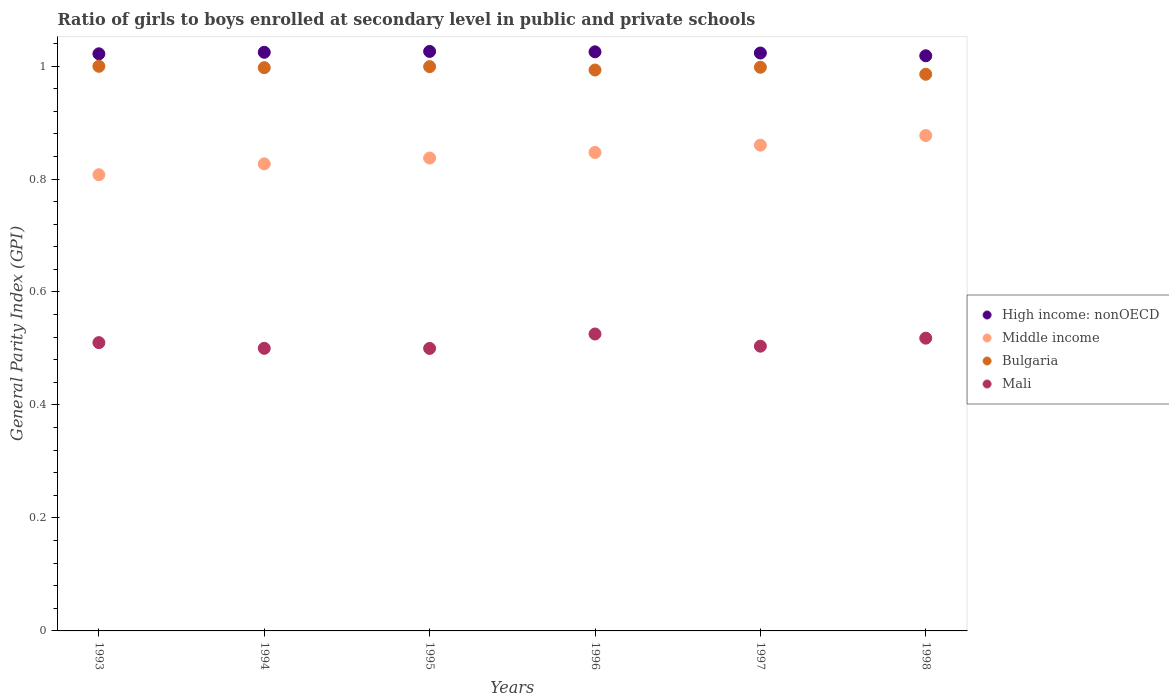How many different coloured dotlines are there?
Your response must be concise. 4. What is the general parity index in Bulgaria in 1995?
Your answer should be compact. 1. Across all years, what is the maximum general parity index in Middle income?
Make the answer very short. 0.88. Across all years, what is the minimum general parity index in Bulgaria?
Ensure brevity in your answer.  0.99. In which year was the general parity index in Bulgaria maximum?
Make the answer very short. 1993. What is the total general parity index in Bulgaria in the graph?
Provide a short and direct response. 5.97. What is the difference between the general parity index in Bulgaria in 1995 and that in 1996?
Offer a terse response. 0.01. What is the difference between the general parity index in Bulgaria in 1995 and the general parity index in Middle income in 1997?
Your response must be concise. 0.14. What is the average general parity index in Mali per year?
Make the answer very short. 0.51. In the year 1998, what is the difference between the general parity index in Bulgaria and general parity index in Mali?
Make the answer very short. 0.47. What is the ratio of the general parity index in Bulgaria in 1994 to that in 1996?
Make the answer very short. 1. What is the difference between the highest and the second highest general parity index in High income: nonOECD?
Your answer should be very brief. 0. What is the difference between the highest and the lowest general parity index in High income: nonOECD?
Make the answer very short. 0.01. Is the sum of the general parity index in Middle income in 1993 and 1994 greater than the maximum general parity index in Mali across all years?
Your answer should be very brief. Yes. Is it the case that in every year, the sum of the general parity index in Mali and general parity index in High income: nonOECD  is greater than the sum of general parity index in Bulgaria and general parity index in Middle income?
Your response must be concise. Yes. Is it the case that in every year, the sum of the general parity index in High income: nonOECD and general parity index in Middle income  is greater than the general parity index in Mali?
Your answer should be compact. Yes. Does the general parity index in Bulgaria monotonically increase over the years?
Your answer should be compact. No. Is the general parity index in Mali strictly greater than the general parity index in Bulgaria over the years?
Ensure brevity in your answer.  No. How many years are there in the graph?
Your answer should be compact. 6. Are the values on the major ticks of Y-axis written in scientific E-notation?
Your answer should be compact. No. How are the legend labels stacked?
Offer a very short reply. Vertical. What is the title of the graph?
Provide a short and direct response. Ratio of girls to boys enrolled at secondary level in public and private schools. What is the label or title of the Y-axis?
Give a very brief answer. General Parity Index (GPI). What is the General Parity Index (GPI) of High income: nonOECD in 1993?
Make the answer very short. 1.02. What is the General Parity Index (GPI) of Middle income in 1993?
Your answer should be compact. 0.81. What is the General Parity Index (GPI) in Bulgaria in 1993?
Give a very brief answer. 1. What is the General Parity Index (GPI) in Mali in 1993?
Keep it short and to the point. 0.51. What is the General Parity Index (GPI) in High income: nonOECD in 1994?
Offer a very short reply. 1.02. What is the General Parity Index (GPI) in Middle income in 1994?
Your answer should be very brief. 0.83. What is the General Parity Index (GPI) in Bulgaria in 1994?
Your response must be concise. 1. What is the General Parity Index (GPI) of Mali in 1994?
Ensure brevity in your answer.  0.5. What is the General Parity Index (GPI) in High income: nonOECD in 1995?
Give a very brief answer. 1.03. What is the General Parity Index (GPI) in Middle income in 1995?
Offer a terse response. 0.84. What is the General Parity Index (GPI) in Bulgaria in 1995?
Provide a short and direct response. 1. What is the General Parity Index (GPI) in Mali in 1995?
Provide a succinct answer. 0.5. What is the General Parity Index (GPI) of High income: nonOECD in 1996?
Provide a succinct answer. 1.03. What is the General Parity Index (GPI) in Middle income in 1996?
Offer a terse response. 0.85. What is the General Parity Index (GPI) of Bulgaria in 1996?
Provide a short and direct response. 0.99. What is the General Parity Index (GPI) of Mali in 1996?
Your answer should be very brief. 0.53. What is the General Parity Index (GPI) of High income: nonOECD in 1997?
Offer a terse response. 1.02. What is the General Parity Index (GPI) of Middle income in 1997?
Provide a short and direct response. 0.86. What is the General Parity Index (GPI) in Bulgaria in 1997?
Make the answer very short. 1. What is the General Parity Index (GPI) in Mali in 1997?
Your response must be concise. 0.5. What is the General Parity Index (GPI) of High income: nonOECD in 1998?
Keep it short and to the point. 1.02. What is the General Parity Index (GPI) of Middle income in 1998?
Make the answer very short. 0.88. What is the General Parity Index (GPI) in Bulgaria in 1998?
Your answer should be compact. 0.99. What is the General Parity Index (GPI) of Mali in 1998?
Provide a short and direct response. 0.52. Across all years, what is the maximum General Parity Index (GPI) in High income: nonOECD?
Keep it short and to the point. 1.03. Across all years, what is the maximum General Parity Index (GPI) of Middle income?
Provide a succinct answer. 0.88. Across all years, what is the maximum General Parity Index (GPI) of Bulgaria?
Offer a very short reply. 1. Across all years, what is the maximum General Parity Index (GPI) of Mali?
Make the answer very short. 0.53. Across all years, what is the minimum General Parity Index (GPI) in High income: nonOECD?
Provide a short and direct response. 1.02. Across all years, what is the minimum General Parity Index (GPI) in Middle income?
Give a very brief answer. 0.81. Across all years, what is the minimum General Parity Index (GPI) of Bulgaria?
Provide a short and direct response. 0.99. Across all years, what is the minimum General Parity Index (GPI) in Mali?
Keep it short and to the point. 0.5. What is the total General Parity Index (GPI) in High income: nonOECD in the graph?
Your answer should be very brief. 6.14. What is the total General Parity Index (GPI) of Middle income in the graph?
Offer a terse response. 5.06. What is the total General Parity Index (GPI) in Bulgaria in the graph?
Keep it short and to the point. 5.97. What is the total General Parity Index (GPI) of Mali in the graph?
Make the answer very short. 3.06. What is the difference between the General Parity Index (GPI) of High income: nonOECD in 1993 and that in 1994?
Make the answer very short. -0. What is the difference between the General Parity Index (GPI) in Middle income in 1993 and that in 1994?
Give a very brief answer. -0.02. What is the difference between the General Parity Index (GPI) of Bulgaria in 1993 and that in 1994?
Provide a succinct answer. 0. What is the difference between the General Parity Index (GPI) in Mali in 1993 and that in 1994?
Provide a succinct answer. 0.01. What is the difference between the General Parity Index (GPI) of High income: nonOECD in 1993 and that in 1995?
Make the answer very short. -0. What is the difference between the General Parity Index (GPI) of Middle income in 1993 and that in 1995?
Offer a very short reply. -0.03. What is the difference between the General Parity Index (GPI) of Bulgaria in 1993 and that in 1995?
Your answer should be compact. 0. What is the difference between the General Parity Index (GPI) of Mali in 1993 and that in 1995?
Ensure brevity in your answer.  0.01. What is the difference between the General Parity Index (GPI) in High income: nonOECD in 1993 and that in 1996?
Your answer should be compact. -0. What is the difference between the General Parity Index (GPI) in Middle income in 1993 and that in 1996?
Provide a short and direct response. -0.04. What is the difference between the General Parity Index (GPI) in Bulgaria in 1993 and that in 1996?
Provide a succinct answer. 0.01. What is the difference between the General Parity Index (GPI) of Mali in 1993 and that in 1996?
Provide a succinct answer. -0.02. What is the difference between the General Parity Index (GPI) in High income: nonOECD in 1993 and that in 1997?
Offer a very short reply. -0. What is the difference between the General Parity Index (GPI) of Middle income in 1993 and that in 1997?
Your answer should be compact. -0.05. What is the difference between the General Parity Index (GPI) of Bulgaria in 1993 and that in 1997?
Keep it short and to the point. 0. What is the difference between the General Parity Index (GPI) of Mali in 1993 and that in 1997?
Ensure brevity in your answer.  0.01. What is the difference between the General Parity Index (GPI) of High income: nonOECD in 1993 and that in 1998?
Your answer should be compact. 0. What is the difference between the General Parity Index (GPI) in Middle income in 1993 and that in 1998?
Ensure brevity in your answer.  -0.07. What is the difference between the General Parity Index (GPI) of Bulgaria in 1993 and that in 1998?
Offer a very short reply. 0.01. What is the difference between the General Parity Index (GPI) of Mali in 1993 and that in 1998?
Give a very brief answer. -0.01. What is the difference between the General Parity Index (GPI) in High income: nonOECD in 1994 and that in 1995?
Your answer should be compact. -0. What is the difference between the General Parity Index (GPI) in Middle income in 1994 and that in 1995?
Provide a succinct answer. -0.01. What is the difference between the General Parity Index (GPI) in Bulgaria in 1994 and that in 1995?
Offer a very short reply. -0. What is the difference between the General Parity Index (GPI) of High income: nonOECD in 1994 and that in 1996?
Keep it short and to the point. -0. What is the difference between the General Parity Index (GPI) of Middle income in 1994 and that in 1996?
Make the answer very short. -0.02. What is the difference between the General Parity Index (GPI) of Bulgaria in 1994 and that in 1996?
Your response must be concise. 0. What is the difference between the General Parity Index (GPI) of Mali in 1994 and that in 1996?
Keep it short and to the point. -0.03. What is the difference between the General Parity Index (GPI) in High income: nonOECD in 1994 and that in 1997?
Give a very brief answer. 0. What is the difference between the General Parity Index (GPI) in Middle income in 1994 and that in 1997?
Your answer should be very brief. -0.03. What is the difference between the General Parity Index (GPI) of Bulgaria in 1994 and that in 1997?
Give a very brief answer. -0. What is the difference between the General Parity Index (GPI) of Mali in 1994 and that in 1997?
Provide a short and direct response. -0. What is the difference between the General Parity Index (GPI) in High income: nonOECD in 1994 and that in 1998?
Give a very brief answer. 0.01. What is the difference between the General Parity Index (GPI) in Middle income in 1994 and that in 1998?
Offer a very short reply. -0.05. What is the difference between the General Parity Index (GPI) in Bulgaria in 1994 and that in 1998?
Give a very brief answer. 0.01. What is the difference between the General Parity Index (GPI) of Mali in 1994 and that in 1998?
Keep it short and to the point. -0.02. What is the difference between the General Parity Index (GPI) in High income: nonOECD in 1995 and that in 1996?
Give a very brief answer. 0. What is the difference between the General Parity Index (GPI) of Middle income in 1995 and that in 1996?
Ensure brevity in your answer.  -0.01. What is the difference between the General Parity Index (GPI) in Bulgaria in 1995 and that in 1996?
Provide a short and direct response. 0.01. What is the difference between the General Parity Index (GPI) of Mali in 1995 and that in 1996?
Ensure brevity in your answer.  -0.03. What is the difference between the General Parity Index (GPI) in High income: nonOECD in 1995 and that in 1997?
Offer a terse response. 0. What is the difference between the General Parity Index (GPI) in Middle income in 1995 and that in 1997?
Make the answer very short. -0.02. What is the difference between the General Parity Index (GPI) of Bulgaria in 1995 and that in 1997?
Give a very brief answer. 0. What is the difference between the General Parity Index (GPI) of Mali in 1995 and that in 1997?
Your answer should be compact. -0. What is the difference between the General Parity Index (GPI) of High income: nonOECD in 1995 and that in 1998?
Your response must be concise. 0.01. What is the difference between the General Parity Index (GPI) in Middle income in 1995 and that in 1998?
Ensure brevity in your answer.  -0.04. What is the difference between the General Parity Index (GPI) in Bulgaria in 1995 and that in 1998?
Make the answer very short. 0.01. What is the difference between the General Parity Index (GPI) of Mali in 1995 and that in 1998?
Your answer should be compact. -0.02. What is the difference between the General Parity Index (GPI) in High income: nonOECD in 1996 and that in 1997?
Offer a terse response. 0. What is the difference between the General Parity Index (GPI) in Middle income in 1996 and that in 1997?
Your answer should be very brief. -0.01. What is the difference between the General Parity Index (GPI) of Bulgaria in 1996 and that in 1997?
Your answer should be compact. -0. What is the difference between the General Parity Index (GPI) of Mali in 1996 and that in 1997?
Your answer should be very brief. 0.02. What is the difference between the General Parity Index (GPI) in High income: nonOECD in 1996 and that in 1998?
Provide a short and direct response. 0.01. What is the difference between the General Parity Index (GPI) in Middle income in 1996 and that in 1998?
Your answer should be very brief. -0.03. What is the difference between the General Parity Index (GPI) of Bulgaria in 1996 and that in 1998?
Offer a very short reply. 0.01. What is the difference between the General Parity Index (GPI) of Mali in 1996 and that in 1998?
Your answer should be compact. 0.01. What is the difference between the General Parity Index (GPI) in High income: nonOECD in 1997 and that in 1998?
Your response must be concise. 0. What is the difference between the General Parity Index (GPI) in Middle income in 1997 and that in 1998?
Keep it short and to the point. -0.02. What is the difference between the General Parity Index (GPI) in Bulgaria in 1997 and that in 1998?
Provide a short and direct response. 0.01. What is the difference between the General Parity Index (GPI) in Mali in 1997 and that in 1998?
Ensure brevity in your answer.  -0.01. What is the difference between the General Parity Index (GPI) of High income: nonOECD in 1993 and the General Parity Index (GPI) of Middle income in 1994?
Keep it short and to the point. 0.19. What is the difference between the General Parity Index (GPI) in High income: nonOECD in 1993 and the General Parity Index (GPI) in Bulgaria in 1994?
Your response must be concise. 0.02. What is the difference between the General Parity Index (GPI) in High income: nonOECD in 1993 and the General Parity Index (GPI) in Mali in 1994?
Give a very brief answer. 0.52. What is the difference between the General Parity Index (GPI) of Middle income in 1993 and the General Parity Index (GPI) of Bulgaria in 1994?
Your answer should be compact. -0.19. What is the difference between the General Parity Index (GPI) in Middle income in 1993 and the General Parity Index (GPI) in Mali in 1994?
Provide a succinct answer. 0.31. What is the difference between the General Parity Index (GPI) of Bulgaria in 1993 and the General Parity Index (GPI) of Mali in 1994?
Keep it short and to the point. 0.5. What is the difference between the General Parity Index (GPI) in High income: nonOECD in 1993 and the General Parity Index (GPI) in Middle income in 1995?
Keep it short and to the point. 0.18. What is the difference between the General Parity Index (GPI) of High income: nonOECD in 1993 and the General Parity Index (GPI) of Bulgaria in 1995?
Make the answer very short. 0.02. What is the difference between the General Parity Index (GPI) in High income: nonOECD in 1993 and the General Parity Index (GPI) in Mali in 1995?
Provide a short and direct response. 0.52. What is the difference between the General Parity Index (GPI) in Middle income in 1993 and the General Parity Index (GPI) in Bulgaria in 1995?
Ensure brevity in your answer.  -0.19. What is the difference between the General Parity Index (GPI) of Middle income in 1993 and the General Parity Index (GPI) of Mali in 1995?
Offer a very short reply. 0.31. What is the difference between the General Parity Index (GPI) in Bulgaria in 1993 and the General Parity Index (GPI) in Mali in 1995?
Offer a very short reply. 0.5. What is the difference between the General Parity Index (GPI) in High income: nonOECD in 1993 and the General Parity Index (GPI) in Middle income in 1996?
Offer a terse response. 0.17. What is the difference between the General Parity Index (GPI) of High income: nonOECD in 1993 and the General Parity Index (GPI) of Bulgaria in 1996?
Ensure brevity in your answer.  0.03. What is the difference between the General Parity Index (GPI) of High income: nonOECD in 1993 and the General Parity Index (GPI) of Mali in 1996?
Make the answer very short. 0.5. What is the difference between the General Parity Index (GPI) of Middle income in 1993 and the General Parity Index (GPI) of Bulgaria in 1996?
Keep it short and to the point. -0.19. What is the difference between the General Parity Index (GPI) of Middle income in 1993 and the General Parity Index (GPI) of Mali in 1996?
Offer a very short reply. 0.28. What is the difference between the General Parity Index (GPI) in Bulgaria in 1993 and the General Parity Index (GPI) in Mali in 1996?
Offer a very short reply. 0.47. What is the difference between the General Parity Index (GPI) of High income: nonOECD in 1993 and the General Parity Index (GPI) of Middle income in 1997?
Offer a terse response. 0.16. What is the difference between the General Parity Index (GPI) of High income: nonOECD in 1993 and the General Parity Index (GPI) of Bulgaria in 1997?
Offer a terse response. 0.02. What is the difference between the General Parity Index (GPI) in High income: nonOECD in 1993 and the General Parity Index (GPI) in Mali in 1997?
Offer a terse response. 0.52. What is the difference between the General Parity Index (GPI) in Middle income in 1993 and the General Parity Index (GPI) in Bulgaria in 1997?
Provide a short and direct response. -0.19. What is the difference between the General Parity Index (GPI) in Middle income in 1993 and the General Parity Index (GPI) in Mali in 1997?
Give a very brief answer. 0.3. What is the difference between the General Parity Index (GPI) in Bulgaria in 1993 and the General Parity Index (GPI) in Mali in 1997?
Offer a terse response. 0.5. What is the difference between the General Parity Index (GPI) of High income: nonOECD in 1993 and the General Parity Index (GPI) of Middle income in 1998?
Provide a short and direct response. 0.14. What is the difference between the General Parity Index (GPI) in High income: nonOECD in 1993 and the General Parity Index (GPI) in Bulgaria in 1998?
Offer a terse response. 0.04. What is the difference between the General Parity Index (GPI) of High income: nonOECD in 1993 and the General Parity Index (GPI) of Mali in 1998?
Keep it short and to the point. 0.5. What is the difference between the General Parity Index (GPI) of Middle income in 1993 and the General Parity Index (GPI) of Bulgaria in 1998?
Offer a terse response. -0.18. What is the difference between the General Parity Index (GPI) in Middle income in 1993 and the General Parity Index (GPI) in Mali in 1998?
Provide a succinct answer. 0.29. What is the difference between the General Parity Index (GPI) of Bulgaria in 1993 and the General Parity Index (GPI) of Mali in 1998?
Offer a very short reply. 0.48. What is the difference between the General Parity Index (GPI) in High income: nonOECD in 1994 and the General Parity Index (GPI) in Middle income in 1995?
Ensure brevity in your answer.  0.19. What is the difference between the General Parity Index (GPI) of High income: nonOECD in 1994 and the General Parity Index (GPI) of Bulgaria in 1995?
Your response must be concise. 0.03. What is the difference between the General Parity Index (GPI) of High income: nonOECD in 1994 and the General Parity Index (GPI) of Mali in 1995?
Keep it short and to the point. 0.52. What is the difference between the General Parity Index (GPI) in Middle income in 1994 and the General Parity Index (GPI) in Bulgaria in 1995?
Ensure brevity in your answer.  -0.17. What is the difference between the General Parity Index (GPI) of Middle income in 1994 and the General Parity Index (GPI) of Mali in 1995?
Give a very brief answer. 0.33. What is the difference between the General Parity Index (GPI) in Bulgaria in 1994 and the General Parity Index (GPI) in Mali in 1995?
Give a very brief answer. 0.5. What is the difference between the General Parity Index (GPI) in High income: nonOECD in 1994 and the General Parity Index (GPI) in Middle income in 1996?
Your response must be concise. 0.18. What is the difference between the General Parity Index (GPI) of High income: nonOECD in 1994 and the General Parity Index (GPI) of Bulgaria in 1996?
Provide a succinct answer. 0.03. What is the difference between the General Parity Index (GPI) of High income: nonOECD in 1994 and the General Parity Index (GPI) of Mali in 1996?
Provide a short and direct response. 0.5. What is the difference between the General Parity Index (GPI) in Middle income in 1994 and the General Parity Index (GPI) in Bulgaria in 1996?
Provide a succinct answer. -0.17. What is the difference between the General Parity Index (GPI) of Middle income in 1994 and the General Parity Index (GPI) of Mali in 1996?
Your response must be concise. 0.3. What is the difference between the General Parity Index (GPI) in Bulgaria in 1994 and the General Parity Index (GPI) in Mali in 1996?
Keep it short and to the point. 0.47. What is the difference between the General Parity Index (GPI) in High income: nonOECD in 1994 and the General Parity Index (GPI) in Middle income in 1997?
Your answer should be very brief. 0.16. What is the difference between the General Parity Index (GPI) of High income: nonOECD in 1994 and the General Parity Index (GPI) of Bulgaria in 1997?
Your answer should be compact. 0.03. What is the difference between the General Parity Index (GPI) in High income: nonOECD in 1994 and the General Parity Index (GPI) in Mali in 1997?
Your answer should be compact. 0.52. What is the difference between the General Parity Index (GPI) of Middle income in 1994 and the General Parity Index (GPI) of Bulgaria in 1997?
Your answer should be very brief. -0.17. What is the difference between the General Parity Index (GPI) in Middle income in 1994 and the General Parity Index (GPI) in Mali in 1997?
Make the answer very short. 0.32. What is the difference between the General Parity Index (GPI) of Bulgaria in 1994 and the General Parity Index (GPI) of Mali in 1997?
Your answer should be compact. 0.49. What is the difference between the General Parity Index (GPI) of High income: nonOECD in 1994 and the General Parity Index (GPI) of Middle income in 1998?
Provide a succinct answer. 0.15. What is the difference between the General Parity Index (GPI) in High income: nonOECD in 1994 and the General Parity Index (GPI) in Bulgaria in 1998?
Make the answer very short. 0.04. What is the difference between the General Parity Index (GPI) in High income: nonOECD in 1994 and the General Parity Index (GPI) in Mali in 1998?
Offer a terse response. 0.51. What is the difference between the General Parity Index (GPI) in Middle income in 1994 and the General Parity Index (GPI) in Bulgaria in 1998?
Ensure brevity in your answer.  -0.16. What is the difference between the General Parity Index (GPI) in Middle income in 1994 and the General Parity Index (GPI) in Mali in 1998?
Offer a terse response. 0.31. What is the difference between the General Parity Index (GPI) of Bulgaria in 1994 and the General Parity Index (GPI) of Mali in 1998?
Give a very brief answer. 0.48. What is the difference between the General Parity Index (GPI) in High income: nonOECD in 1995 and the General Parity Index (GPI) in Middle income in 1996?
Offer a terse response. 0.18. What is the difference between the General Parity Index (GPI) of High income: nonOECD in 1995 and the General Parity Index (GPI) of Bulgaria in 1996?
Keep it short and to the point. 0.03. What is the difference between the General Parity Index (GPI) of High income: nonOECD in 1995 and the General Parity Index (GPI) of Mali in 1996?
Your answer should be very brief. 0.5. What is the difference between the General Parity Index (GPI) of Middle income in 1995 and the General Parity Index (GPI) of Bulgaria in 1996?
Provide a short and direct response. -0.16. What is the difference between the General Parity Index (GPI) of Middle income in 1995 and the General Parity Index (GPI) of Mali in 1996?
Your response must be concise. 0.31. What is the difference between the General Parity Index (GPI) in Bulgaria in 1995 and the General Parity Index (GPI) in Mali in 1996?
Ensure brevity in your answer.  0.47. What is the difference between the General Parity Index (GPI) in High income: nonOECD in 1995 and the General Parity Index (GPI) in Middle income in 1997?
Keep it short and to the point. 0.17. What is the difference between the General Parity Index (GPI) in High income: nonOECD in 1995 and the General Parity Index (GPI) in Bulgaria in 1997?
Make the answer very short. 0.03. What is the difference between the General Parity Index (GPI) in High income: nonOECD in 1995 and the General Parity Index (GPI) in Mali in 1997?
Your answer should be very brief. 0.52. What is the difference between the General Parity Index (GPI) in Middle income in 1995 and the General Parity Index (GPI) in Bulgaria in 1997?
Keep it short and to the point. -0.16. What is the difference between the General Parity Index (GPI) of Middle income in 1995 and the General Parity Index (GPI) of Mali in 1997?
Your answer should be very brief. 0.33. What is the difference between the General Parity Index (GPI) of Bulgaria in 1995 and the General Parity Index (GPI) of Mali in 1997?
Make the answer very short. 0.49. What is the difference between the General Parity Index (GPI) of High income: nonOECD in 1995 and the General Parity Index (GPI) of Middle income in 1998?
Your answer should be very brief. 0.15. What is the difference between the General Parity Index (GPI) of High income: nonOECD in 1995 and the General Parity Index (GPI) of Bulgaria in 1998?
Your answer should be very brief. 0.04. What is the difference between the General Parity Index (GPI) in High income: nonOECD in 1995 and the General Parity Index (GPI) in Mali in 1998?
Give a very brief answer. 0.51. What is the difference between the General Parity Index (GPI) in Middle income in 1995 and the General Parity Index (GPI) in Bulgaria in 1998?
Your answer should be very brief. -0.15. What is the difference between the General Parity Index (GPI) in Middle income in 1995 and the General Parity Index (GPI) in Mali in 1998?
Provide a succinct answer. 0.32. What is the difference between the General Parity Index (GPI) in Bulgaria in 1995 and the General Parity Index (GPI) in Mali in 1998?
Your response must be concise. 0.48. What is the difference between the General Parity Index (GPI) of High income: nonOECD in 1996 and the General Parity Index (GPI) of Middle income in 1997?
Give a very brief answer. 0.17. What is the difference between the General Parity Index (GPI) of High income: nonOECD in 1996 and the General Parity Index (GPI) of Bulgaria in 1997?
Keep it short and to the point. 0.03. What is the difference between the General Parity Index (GPI) of High income: nonOECD in 1996 and the General Parity Index (GPI) of Mali in 1997?
Your response must be concise. 0.52. What is the difference between the General Parity Index (GPI) in Middle income in 1996 and the General Parity Index (GPI) in Bulgaria in 1997?
Your response must be concise. -0.15. What is the difference between the General Parity Index (GPI) of Middle income in 1996 and the General Parity Index (GPI) of Mali in 1997?
Give a very brief answer. 0.34. What is the difference between the General Parity Index (GPI) in Bulgaria in 1996 and the General Parity Index (GPI) in Mali in 1997?
Keep it short and to the point. 0.49. What is the difference between the General Parity Index (GPI) in High income: nonOECD in 1996 and the General Parity Index (GPI) in Middle income in 1998?
Make the answer very short. 0.15. What is the difference between the General Parity Index (GPI) in High income: nonOECD in 1996 and the General Parity Index (GPI) in Bulgaria in 1998?
Provide a short and direct response. 0.04. What is the difference between the General Parity Index (GPI) of High income: nonOECD in 1996 and the General Parity Index (GPI) of Mali in 1998?
Your response must be concise. 0.51. What is the difference between the General Parity Index (GPI) of Middle income in 1996 and the General Parity Index (GPI) of Bulgaria in 1998?
Give a very brief answer. -0.14. What is the difference between the General Parity Index (GPI) in Middle income in 1996 and the General Parity Index (GPI) in Mali in 1998?
Your answer should be very brief. 0.33. What is the difference between the General Parity Index (GPI) of Bulgaria in 1996 and the General Parity Index (GPI) of Mali in 1998?
Provide a short and direct response. 0.47. What is the difference between the General Parity Index (GPI) of High income: nonOECD in 1997 and the General Parity Index (GPI) of Middle income in 1998?
Keep it short and to the point. 0.15. What is the difference between the General Parity Index (GPI) of High income: nonOECD in 1997 and the General Parity Index (GPI) of Bulgaria in 1998?
Offer a very short reply. 0.04. What is the difference between the General Parity Index (GPI) in High income: nonOECD in 1997 and the General Parity Index (GPI) in Mali in 1998?
Make the answer very short. 0.5. What is the difference between the General Parity Index (GPI) in Middle income in 1997 and the General Parity Index (GPI) in Bulgaria in 1998?
Offer a terse response. -0.13. What is the difference between the General Parity Index (GPI) in Middle income in 1997 and the General Parity Index (GPI) in Mali in 1998?
Offer a very short reply. 0.34. What is the difference between the General Parity Index (GPI) in Bulgaria in 1997 and the General Parity Index (GPI) in Mali in 1998?
Your response must be concise. 0.48. What is the average General Parity Index (GPI) in High income: nonOECD per year?
Provide a short and direct response. 1.02. What is the average General Parity Index (GPI) in Middle income per year?
Ensure brevity in your answer.  0.84. What is the average General Parity Index (GPI) in Bulgaria per year?
Make the answer very short. 1. What is the average General Parity Index (GPI) in Mali per year?
Offer a very short reply. 0.51. In the year 1993, what is the difference between the General Parity Index (GPI) of High income: nonOECD and General Parity Index (GPI) of Middle income?
Offer a very short reply. 0.21. In the year 1993, what is the difference between the General Parity Index (GPI) of High income: nonOECD and General Parity Index (GPI) of Bulgaria?
Give a very brief answer. 0.02. In the year 1993, what is the difference between the General Parity Index (GPI) of High income: nonOECD and General Parity Index (GPI) of Mali?
Make the answer very short. 0.51. In the year 1993, what is the difference between the General Parity Index (GPI) in Middle income and General Parity Index (GPI) in Bulgaria?
Provide a short and direct response. -0.19. In the year 1993, what is the difference between the General Parity Index (GPI) in Middle income and General Parity Index (GPI) in Mali?
Offer a very short reply. 0.3. In the year 1993, what is the difference between the General Parity Index (GPI) in Bulgaria and General Parity Index (GPI) in Mali?
Ensure brevity in your answer.  0.49. In the year 1994, what is the difference between the General Parity Index (GPI) of High income: nonOECD and General Parity Index (GPI) of Middle income?
Your answer should be very brief. 0.2. In the year 1994, what is the difference between the General Parity Index (GPI) in High income: nonOECD and General Parity Index (GPI) in Bulgaria?
Ensure brevity in your answer.  0.03. In the year 1994, what is the difference between the General Parity Index (GPI) of High income: nonOECD and General Parity Index (GPI) of Mali?
Keep it short and to the point. 0.52. In the year 1994, what is the difference between the General Parity Index (GPI) in Middle income and General Parity Index (GPI) in Bulgaria?
Make the answer very short. -0.17. In the year 1994, what is the difference between the General Parity Index (GPI) in Middle income and General Parity Index (GPI) in Mali?
Provide a short and direct response. 0.33. In the year 1994, what is the difference between the General Parity Index (GPI) in Bulgaria and General Parity Index (GPI) in Mali?
Give a very brief answer. 0.5. In the year 1995, what is the difference between the General Parity Index (GPI) of High income: nonOECD and General Parity Index (GPI) of Middle income?
Provide a succinct answer. 0.19. In the year 1995, what is the difference between the General Parity Index (GPI) in High income: nonOECD and General Parity Index (GPI) in Bulgaria?
Your answer should be very brief. 0.03. In the year 1995, what is the difference between the General Parity Index (GPI) in High income: nonOECD and General Parity Index (GPI) in Mali?
Offer a very short reply. 0.53. In the year 1995, what is the difference between the General Parity Index (GPI) of Middle income and General Parity Index (GPI) of Bulgaria?
Make the answer very short. -0.16. In the year 1995, what is the difference between the General Parity Index (GPI) of Middle income and General Parity Index (GPI) of Mali?
Keep it short and to the point. 0.34. In the year 1995, what is the difference between the General Parity Index (GPI) of Bulgaria and General Parity Index (GPI) of Mali?
Make the answer very short. 0.5. In the year 1996, what is the difference between the General Parity Index (GPI) in High income: nonOECD and General Parity Index (GPI) in Middle income?
Offer a terse response. 0.18. In the year 1996, what is the difference between the General Parity Index (GPI) of High income: nonOECD and General Parity Index (GPI) of Bulgaria?
Your answer should be very brief. 0.03. In the year 1996, what is the difference between the General Parity Index (GPI) of High income: nonOECD and General Parity Index (GPI) of Mali?
Provide a succinct answer. 0.5. In the year 1996, what is the difference between the General Parity Index (GPI) of Middle income and General Parity Index (GPI) of Bulgaria?
Provide a succinct answer. -0.15. In the year 1996, what is the difference between the General Parity Index (GPI) of Middle income and General Parity Index (GPI) of Mali?
Your answer should be very brief. 0.32. In the year 1996, what is the difference between the General Parity Index (GPI) of Bulgaria and General Parity Index (GPI) of Mali?
Give a very brief answer. 0.47. In the year 1997, what is the difference between the General Parity Index (GPI) in High income: nonOECD and General Parity Index (GPI) in Middle income?
Make the answer very short. 0.16. In the year 1997, what is the difference between the General Parity Index (GPI) of High income: nonOECD and General Parity Index (GPI) of Bulgaria?
Make the answer very short. 0.03. In the year 1997, what is the difference between the General Parity Index (GPI) in High income: nonOECD and General Parity Index (GPI) in Mali?
Ensure brevity in your answer.  0.52. In the year 1997, what is the difference between the General Parity Index (GPI) of Middle income and General Parity Index (GPI) of Bulgaria?
Offer a very short reply. -0.14. In the year 1997, what is the difference between the General Parity Index (GPI) in Middle income and General Parity Index (GPI) in Mali?
Give a very brief answer. 0.36. In the year 1997, what is the difference between the General Parity Index (GPI) in Bulgaria and General Parity Index (GPI) in Mali?
Give a very brief answer. 0.49. In the year 1998, what is the difference between the General Parity Index (GPI) in High income: nonOECD and General Parity Index (GPI) in Middle income?
Make the answer very short. 0.14. In the year 1998, what is the difference between the General Parity Index (GPI) in High income: nonOECD and General Parity Index (GPI) in Bulgaria?
Give a very brief answer. 0.03. In the year 1998, what is the difference between the General Parity Index (GPI) in High income: nonOECD and General Parity Index (GPI) in Mali?
Your answer should be compact. 0.5. In the year 1998, what is the difference between the General Parity Index (GPI) of Middle income and General Parity Index (GPI) of Bulgaria?
Keep it short and to the point. -0.11. In the year 1998, what is the difference between the General Parity Index (GPI) in Middle income and General Parity Index (GPI) in Mali?
Make the answer very short. 0.36. In the year 1998, what is the difference between the General Parity Index (GPI) of Bulgaria and General Parity Index (GPI) of Mali?
Provide a succinct answer. 0.47. What is the ratio of the General Parity Index (GPI) in Middle income in 1993 to that in 1994?
Provide a succinct answer. 0.98. What is the ratio of the General Parity Index (GPI) in Mali in 1993 to that in 1994?
Provide a succinct answer. 1.02. What is the ratio of the General Parity Index (GPI) of Middle income in 1993 to that in 1995?
Offer a terse response. 0.96. What is the ratio of the General Parity Index (GPI) of Bulgaria in 1993 to that in 1995?
Offer a terse response. 1. What is the ratio of the General Parity Index (GPI) in Mali in 1993 to that in 1995?
Give a very brief answer. 1.02. What is the ratio of the General Parity Index (GPI) in High income: nonOECD in 1993 to that in 1996?
Provide a succinct answer. 1. What is the ratio of the General Parity Index (GPI) of Middle income in 1993 to that in 1996?
Provide a succinct answer. 0.95. What is the ratio of the General Parity Index (GPI) of Bulgaria in 1993 to that in 1996?
Your answer should be compact. 1.01. What is the ratio of the General Parity Index (GPI) of Mali in 1993 to that in 1996?
Provide a succinct answer. 0.97. What is the ratio of the General Parity Index (GPI) in High income: nonOECD in 1993 to that in 1997?
Your answer should be very brief. 1. What is the ratio of the General Parity Index (GPI) in Middle income in 1993 to that in 1997?
Keep it short and to the point. 0.94. What is the ratio of the General Parity Index (GPI) in Bulgaria in 1993 to that in 1997?
Give a very brief answer. 1. What is the ratio of the General Parity Index (GPI) in Mali in 1993 to that in 1997?
Ensure brevity in your answer.  1.01. What is the ratio of the General Parity Index (GPI) in Middle income in 1993 to that in 1998?
Make the answer very short. 0.92. What is the ratio of the General Parity Index (GPI) in Bulgaria in 1993 to that in 1998?
Ensure brevity in your answer.  1.01. What is the ratio of the General Parity Index (GPI) of Mali in 1993 to that in 1998?
Ensure brevity in your answer.  0.98. What is the ratio of the General Parity Index (GPI) of High income: nonOECD in 1994 to that in 1995?
Provide a short and direct response. 1. What is the ratio of the General Parity Index (GPI) in Middle income in 1994 to that in 1995?
Your response must be concise. 0.99. What is the ratio of the General Parity Index (GPI) of Mali in 1994 to that in 1995?
Keep it short and to the point. 1. What is the ratio of the General Parity Index (GPI) in High income: nonOECD in 1994 to that in 1996?
Provide a short and direct response. 1. What is the ratio of the General Parity Index (GPI) of Middle income in 1994 to that in 1996?
Offer a terse response. 0.98. What is the ratio of the General Parity Index (GPI) in Mali in 1994 to that in 1996?
Provide a succinct answer. 0.95. What is the ratio of the General Parity Index (GPI) of Middle income in 1994 to that in 1997?
Provide a succinct answer. 0.96. What is the ratio of the General Parity Index (GPI) of Mali in 1994 to that in 1997?
Your answer should be compact. 0.99. What is the ratio of the General Parity Index (GPI) of Middle income in 1994 to that in 1998?
Keep it short and to the point. 0.94. What is the ratio of the General Parity Index (GPI) in Bulgaria in 1994 to that in 1998?
Provide a succinct answer. 1.01. What is the ratio of the General Parity Index (GPI) in Mali in 1994 to that in 1998?
Ensure brevity in your answer.  0.97. What is the ratio of the General Parity Index (GPI) in High income: nonOECD in 1995 to that in 1996?
Keep it short and to the point. 1. What is the ratio of the General Parity Index (GPI) of Middle income in 1995 to that in 1996?
Give a very brief answer. 0.99. What is the ratio of the General Parity Index (GPI) of Mali in 1995 to that in 1996?
Your response must be concise. 0.95. What is the ratio of the General Parity Index (GPI) in High income: nonOECD in 1995 to that in 1997?
Provide a succinct answer. 1. What is the ratio of the General Parity Index (GPI) of Middle income in 1995 to that in 1997?
Give a very brief answer. 0.97. What is the ratio of the General Parity Index (GPI) in Mali in 1995 to that in 1997?
Your response must be concise. 0.99. What is the ratio of the General Parity Index (GPI) of High income: nonOECD in 1995 to that in 1998?
Keep it short and to the point. 1.01. What is the ratio of the General Parity Index (GPI) in Middle income in 1995 to that in 1998?
Provide a short and direct response. 0.95. What is the ratio of the General Parity Index (GPI) in Bulgaria in 1995 to that in 1998?
Ensure brevity in your answer.  1.01. What is the ratio of the General Parity Index (GPI) in High income: nonOECD in 1996 to that in 1997?
Ensure brevity in your answer.  1. What is the ratio of the General Parity Index (GPI) of Middle income in 1996 to that in 1997?
Make the answer very short. 0.98. What is the ratio of the General Parity Index (GPI) of Mali in 1996 to that in 1997?
Provide a succinct answer. 1.04. What is the ratio of the General Parity Index (GPI) in Middle income in 1996 to that in 1998?
Keep it short and to the point. 0.97. What is the ratio of the General Parity Index (GPI) in Bulgaria in 1996 to that in 1998?
Offer a terse response. 1.01. What is the ratio of the General Parity Index (GPI) in Mali in 1996 to that in 1998?
Keep it short and to the point. 1.01. What is the ratio of the General Parity Index (GPI) in Middle income in 1997 to that in 1998?
Your answer should be compact. 0.98. What is the ratio of the General Parity Index (GPI) of Bulgaria in 1997 to that in 1998?
Provide a succinct answer. 1.01. What is the ratio of the General Parity Index (GPI) of Mali in 1997 to that in 1998?
Your answer should be very brief. 0.97. What is the difference between the highest and the second highest General Parity Index (GPI) in High income: nonOECD?
Offer a very short reply. 0. What is the difference between the highest and the second highest General Parity Index (GPI) of Middle income?
Your answer should be very brief. 0.02. What is the difference between the highest and the second highest General Parity Index (GPI) of Bulgaria?
Offer a very short reply. 0. What is the difference between the highest and the second highest General Parity Index (GPI) of Mali?
Your response must be concise. 0.01. What is the difference between the highest and the lowest General Parity Index (GPI) of High income: nonOECD?
Your answer should be very brief. 0.01. What is the difference between the highest and the lowest General Parity Index (GPI) in Middle income?
Your answer should be compact. 0.07. What is the difference between the highest and the lowest General Parity Index (GPI) of Bulgaria?
Provide a succinct answer. 0.01. What is the difference between the highest and the lowest General Parity Index (GPI) in Mali?
Provide a short and direct response. 0.03. 